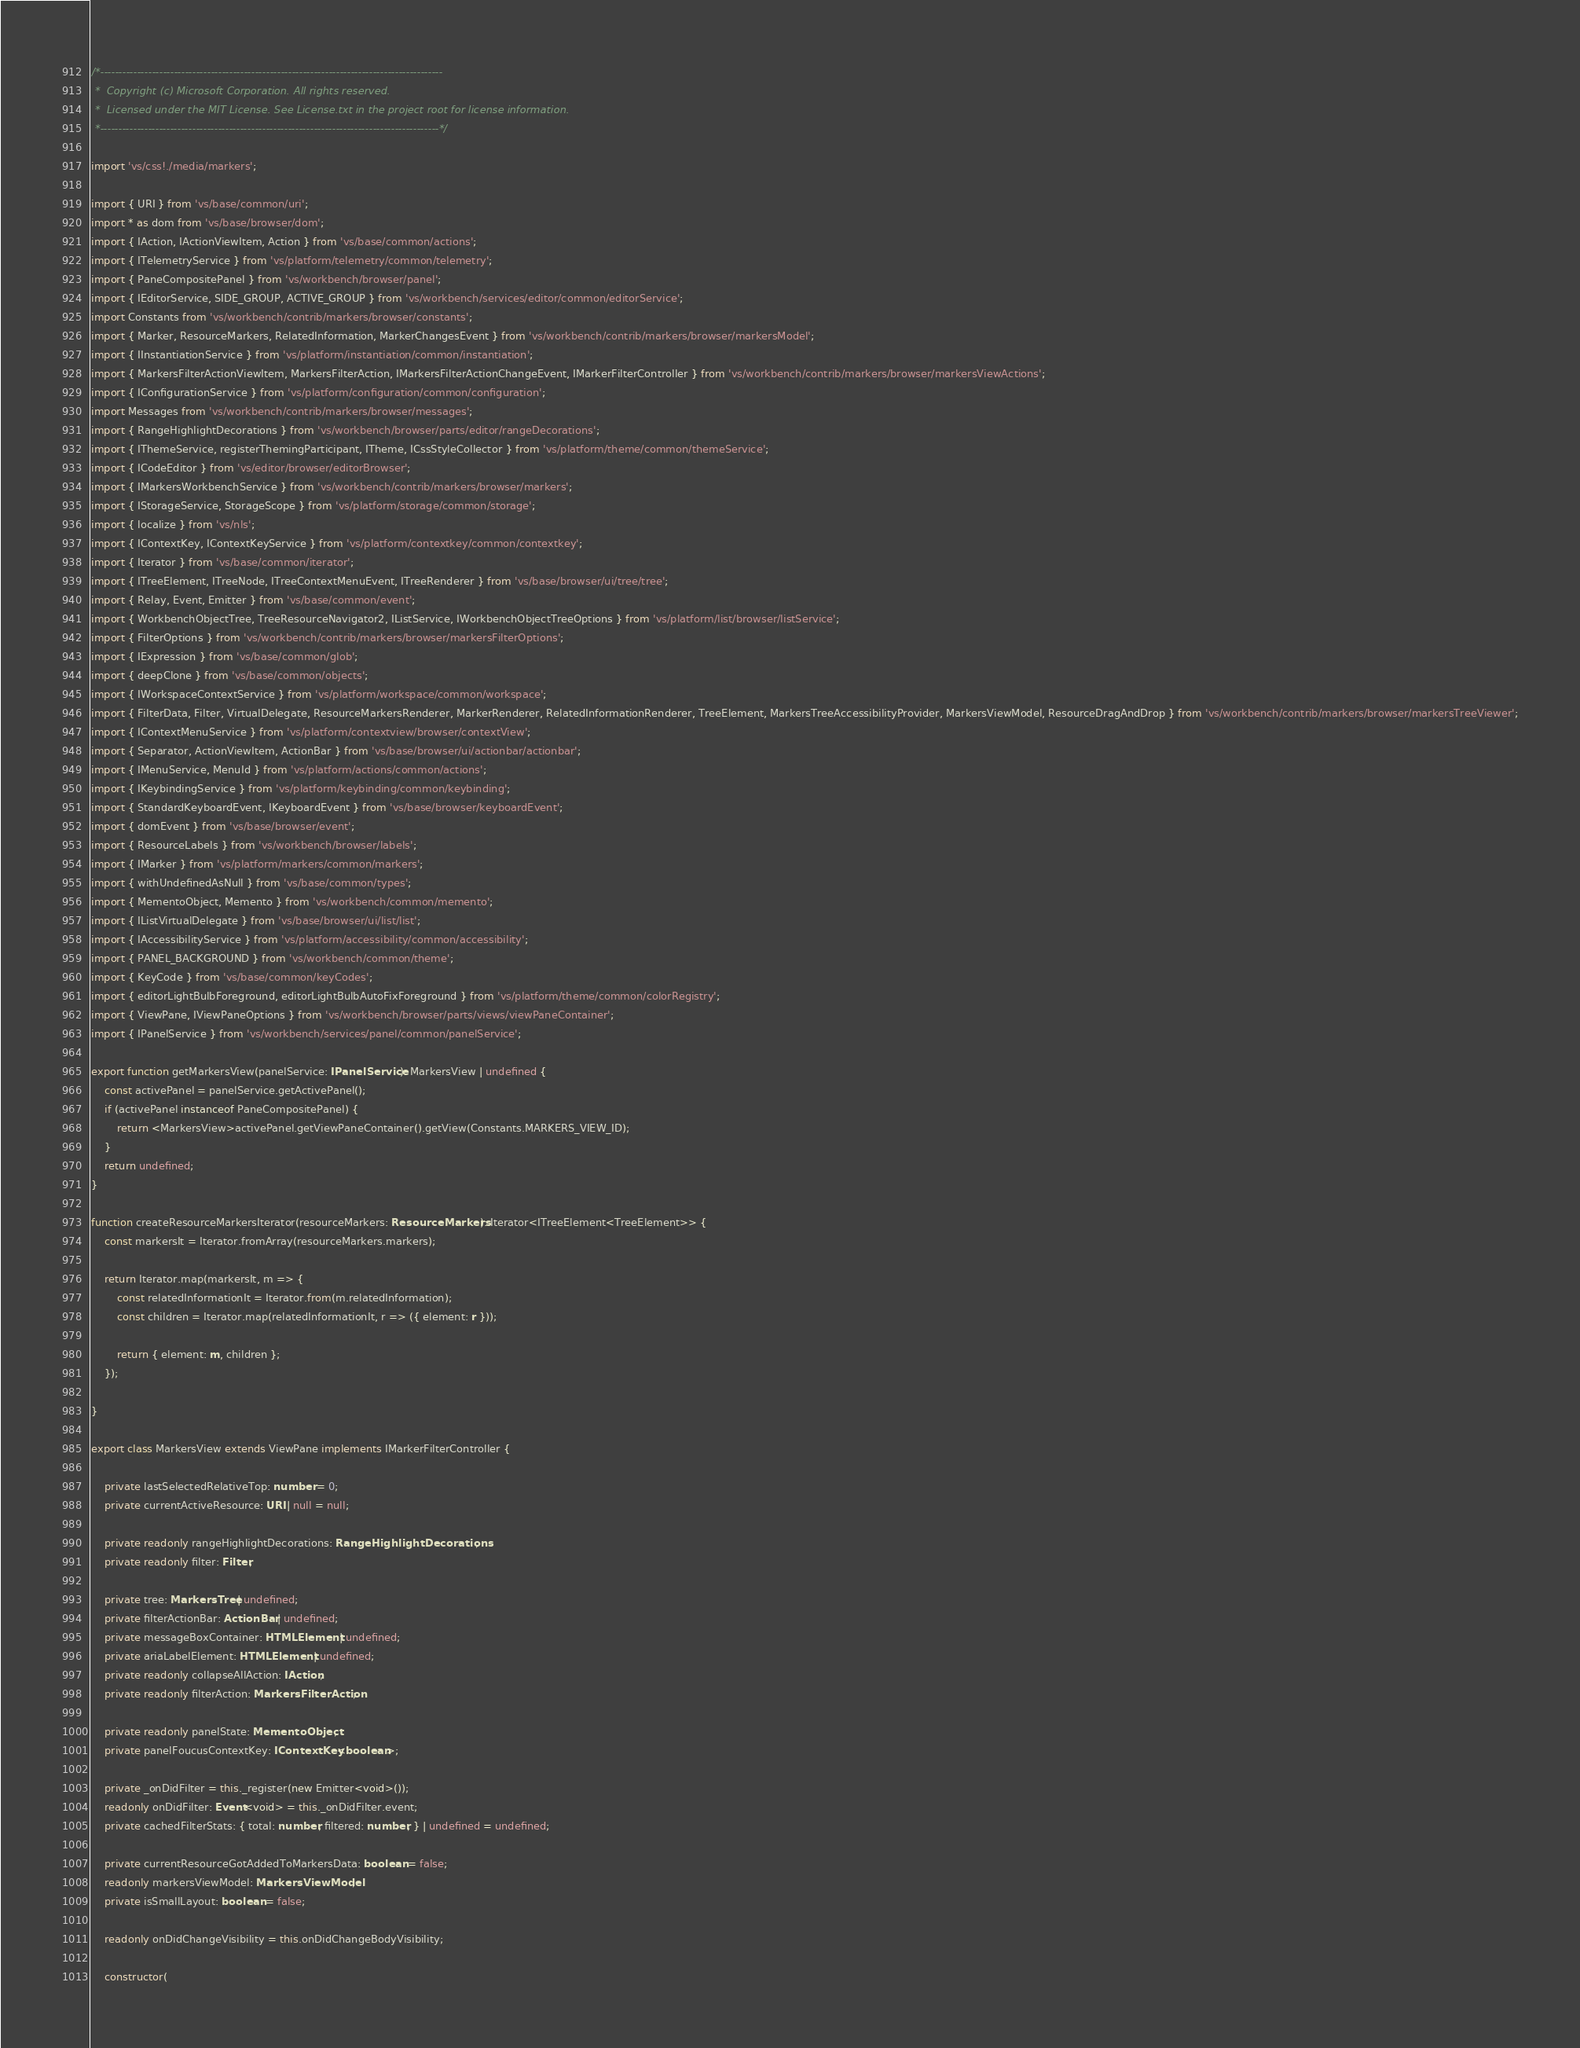Convert code to text. <code><loc_0><loc_0><loc_500><loc_500><_TypeScript_>/*---------------------------------------------------------------------------------------------
 *  Copyright (c) Microsoft Corporation. All rights reserved.
 *  Licensed under the MIT License. See License.txt in the project root for license information.
 *--------------------------------------------------------------------------------------------*/

import 'vs/css!./media/markers';

import { URI } from 'vs/base/common/uri';
import * as dom from 'vs/base/browser/dom';
import { IAction, IActionViewItem, Action } from 'vs/base/common/actions';
import { ITelemetryService } from 'vs/platform/telemetry/common/telemetry';
import { PaneCompositePanel } from 'vs/workbench/browser/panel';
import { IEditorService, SIDE_GROUP, ACTIVE_GROUP } from 'vs/workbench/services/editor/common/editorService';
import Constants from 'vs/workbench/contrib/markers/browser/constants';
import { Marker, ResourceMarkers, RelatedInformation, MarkerChangesEvent } from 'vs/workbench/contrib/markers/browser/markersModel';
import { IInstantiationService } from 'vs/platform/instantiation/common/instantiation';
import { MarkersFilterActionViewItem, MarkersFilterAction, IMarkersFilterActionChangeEvent, IMarkerFilterController } from 'vs/workbench/contrib/markers/browser/markersViewActions';
import { IConfigurationService } from 'vs/platform/configuration/common/configuration';
import Messages from 'vs/workbench/contrib/markers/browser/messages';
import { RangeHighlightDecorations } from 'vs/workbench/browser/parts/editor/rangeDecorations';
import { IThemeService, registerThemingParticipant, ITheme, ICssStyleCollector } from 'vs/platform/theme/common/themeService';
import { ICodeEditor } from 'vs/editor/browser/editorBrowser';
import { IMarkersWorkbenchService } from 'vs/workbench/contrib/markers/browser/markers';
import { IStorageService, StorageScope } from 'vs/platform/storage/common/storage';
import { localize } from 'vs/nls';
import { IContextKey, IContextKeyService } from 'vs/platform/contextkey/common/contextkey';
import { Iterator } from 'vs/base/common/iterator';
import { ITreeElement, ITreeNode, ITreeContextMenuEvent, ITreeRenderer } from 'vs/base/browser/ui/tree/tree';
import { Relay, Event, Emitter } from 'vs/base/common/event';
import { WorkbenchObjectTree, TreeResourceNavigator2, IListService, IWorkbenchObjectTreeOptions } from 'vs/platform/list/browser/listService';
import { FilterOptions } from 'vs/workbench/contrib/markers/browser/markersFilterOptions';
import { IExpression } from 'vs/base/common/glob';
import { deepClone } from 'vs/base/common/objects';
import { IWorkspaceContextService } from 'vs/platform/workspace/common/workspace';
import { FilterData, Filter, VirtualDelegate, ResourceMarkersRenderer, MarkerRenderer, RelatedInformationRenderer, TreeElement, MarkersTreeAccessibilityProvider, MarkersViewModel, ResourceDragAndDrop } from 'vs/workbench/contrib/markers/browser/markersTreeViewer';
import { IContextMenuService } from 'vs/platform/contextview/browser/contextView';
import { Separator, ActionViewItem, ActionBar } from 'vs/base/browser/ui/actionbar/actionbar';
import { IMenuService, MenuId } from 'vs/platform/actions/common/actions';
import { IKeybindingService } from 'vs/platform/keybinding/common/keybinding';
import { StandardKeyboardEvent, IKeyboardEvent } from 'vs/base/browser/keyboardEvent';
import { domEvent } from 'vs/base/browser/event';
import { ResourceLabels } from 'vs/workbench/browser/labels';
import { IMarker } from 'vs/platform/markers/common/markers';
import { withUndefinedAsNull } from 'vs/base/common/types';
import { MementoObject, Memento } from 'vs/workbench/common/memento';
import { IListVirtualDelegate } from 'vs/base/browser/ui/list/list';
import { IAccessibilityService } from 'vs/platform/accessibility/common/accessibility';
import { PANEL_BACKGROUND } from 'vs/workbench/common/theme';
import { KeyCode } from 'vs/base/common/keyCodes';
import { editorLightBulbForeground, editorLightBulbAutoFixForeground } from 'vs/platform/theme/common/colorRegistry';
import { ViewPane, IViewPaneOptions } from 'vs/workbench/browser/parts/views/viewPaneContainer';
import { IPanelService } from 'vs/workbench/services/panel/common/panelService';

export function getMarkersView(panelService: IPanelService): MarkersView | undefined {
	const activePanel = panelService.getActivePanel();
	if (activePanel instanceof PaneCompositePanel) {
		return <MarkersView>activePanel.getViewPaneContainer().getView(Constants.MARKERS_VIEW_ID);
	}
	return undefined;
}

function createResourceMarkersIterator(resourceMarkers: ResourceMarkers): Iterator<ITreeElement<TreeElement>> {
	const markersIt = Iterator.fromArray(resourceMarkers.markers);

	return Iterator.map(markersIt, m => {
		const relatedInformationIt = Iterator.from(m.relatedInformation);
		const children = Iterator.map(relatedInformationIt, r => ({ element: r }));

		return { element: m, children };
	});

}

export class MarkersView extends ViewPane implements IMarkerFilterController {

	private lastSelectedRelativeTop: number = 0;
	private currentActiveResource: URI | null = null;

	private readonly rangeHighlightDecorations: RangeHighlightDecorations;
	private readonly filter: Filter;

	private tree: MarkersTree | undefined;
	private filterActionBar: ActionBar | undefined;
	private messageBoxContainer: HTMLElement | undefined;
	private ariaLabelElement: HTMLElement | undefined;
	private readonly collapseAllAction: IAction;
	private readonly filterAction: MarkersFilterAction;

	private readonly panelState: MementoObject;
	private panelFoucusContextKey: IContextKey<boolean>;

	private _onDidFilter = this._register(new Emitter<void>());
	readonly onDidFilter: Event<void> = this._onDidFilter.event;
	private cachedFilterStats: { total: number; filtered: number; } | undefined = undefined;

	private currentResourceGotAddedToMarkersData: boolean = false;
	readonly markersViewModel: MarkersViewModel;
	private isSmallLayout: boolean = false;

	readonly onDidChangeVisibility = this.onDidChangeBodyVisibility;

	constructor(</code> 